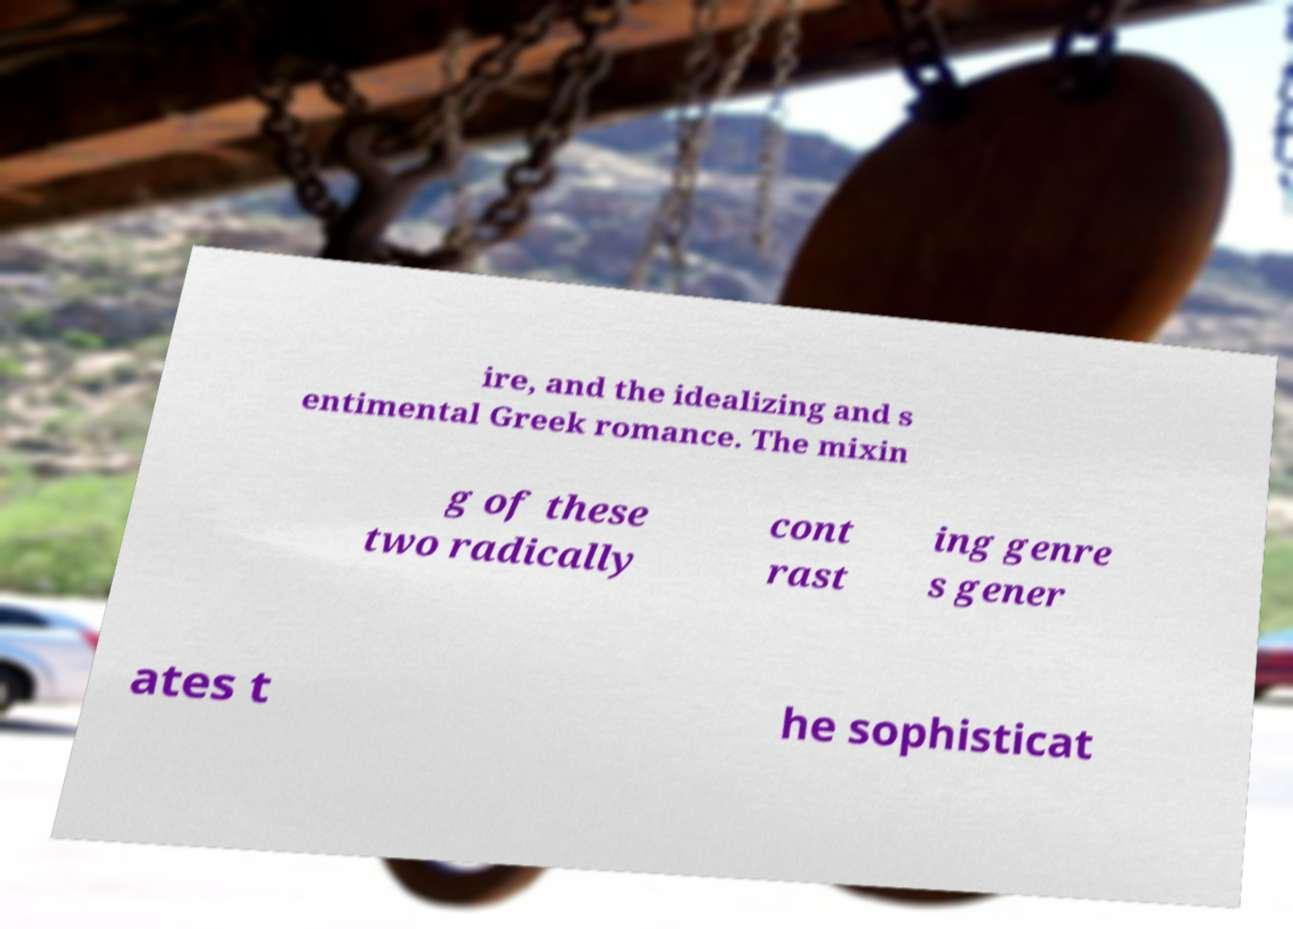Can you read and provide the text displayed in the image?This photo seems to have some interesting text. Can you extract and type it out for me? ire, and the idealizing and s entimental Greek romance. The mixin g of these two radically cont rast ing genre s gener ates t he sophisticat 